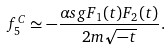<formula> <loc_0><loc_0><loc_500><loc_500>f ^ { C } _ { 5 } \simeq - \frac { \alpha s g F _ { 1 } ( t ) F _ { 2 } ( t ) } { 2 m \sqrt { - t } } .</formula> 